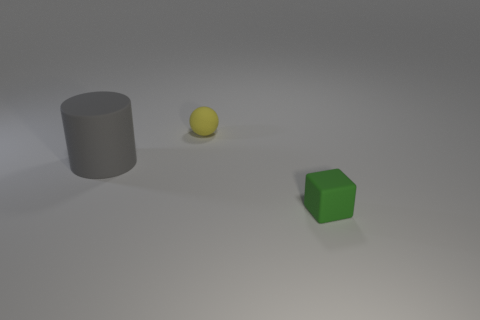Add 1 large brown objects. How many objects exist? 4 Subtract all cubes. How many objects are left? 2 Subtract all purple spheres. Subtract all brown blocks. How many spheres are left? 1 Subtract all tiny matte things. Subtract all small gray shiny cubes. How many objects are left? 1 Add 3 tiny yellow balls. How many tiny yellow balls are left? 4 Add 1 cubes. How many cubes exist? 2 Subtract 0 red balls. How many objects are left? 3 